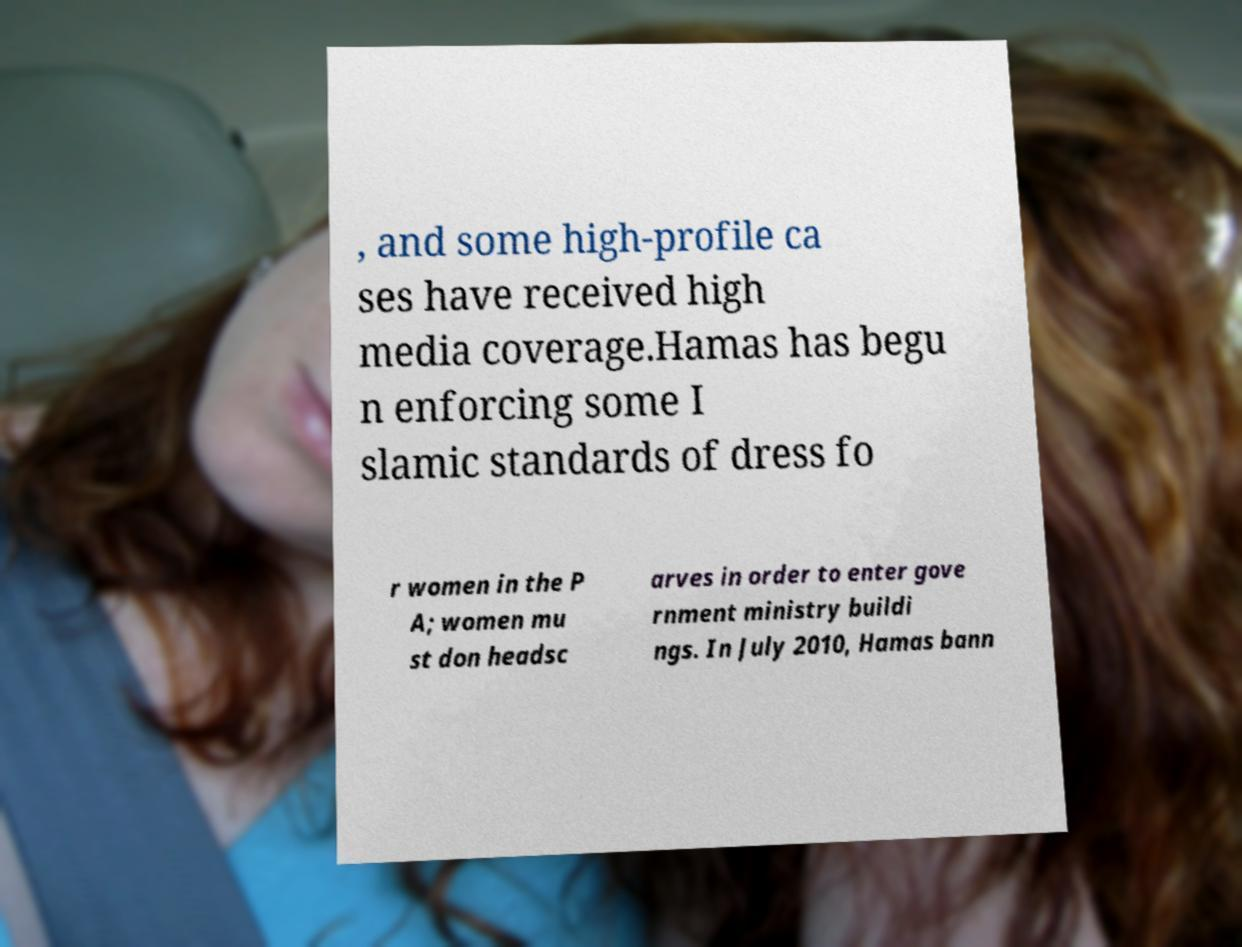Could you extract and type out the text from this image? , and some high-profile ca ses have received high media coverage.Hamas has begu n enforcing some I slamic standards of dress fo r women in the P A; women mu st don headsc arves in order to enter gove rnment ministry buildi ngs. In July 2010, Hamas bann 